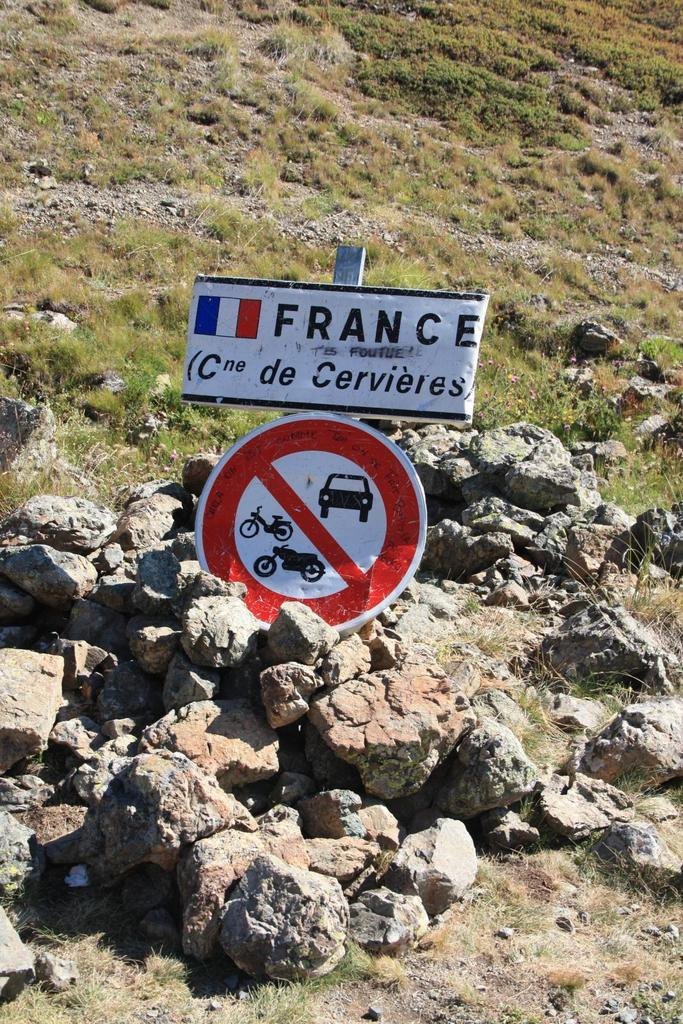<image>
Relay a brief, clear account of the picture shown. A sign written in French warns people not to use motor vehicles in the area. 